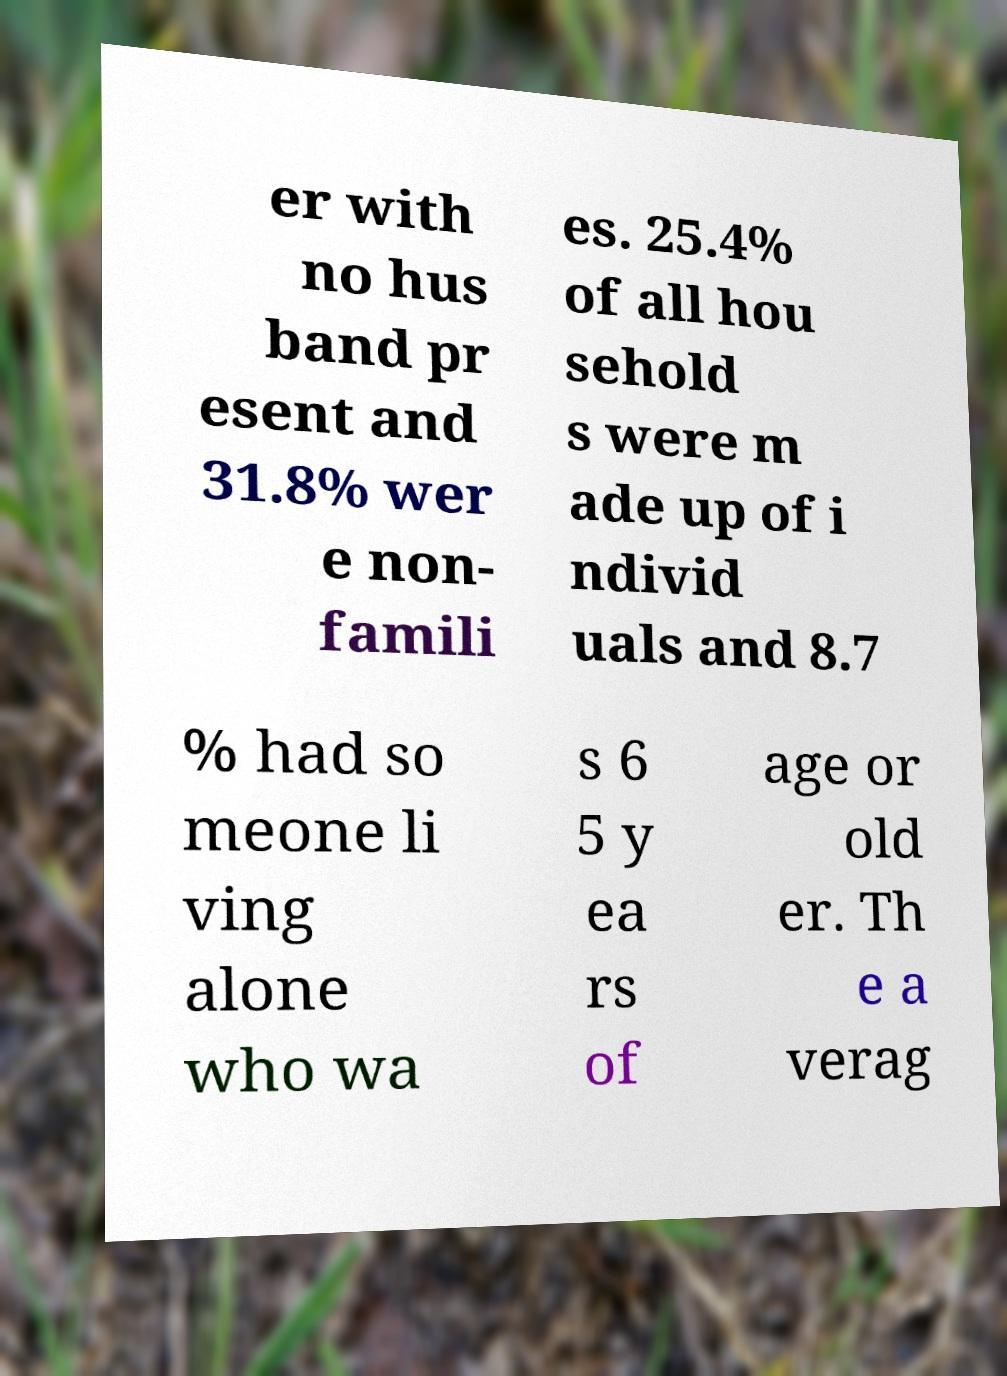There's text embedded in this image that I need extracted. Can you transcribe it verbatim? er with no hus band pr esent and 31.8% wer e non- famili es. 25.4% of all hou sehold s were m ade up of i ndivid uals and 8.7 % had so meone li ving alone who wa s 6 5 y ea rs of age or old er. Th e a verag 